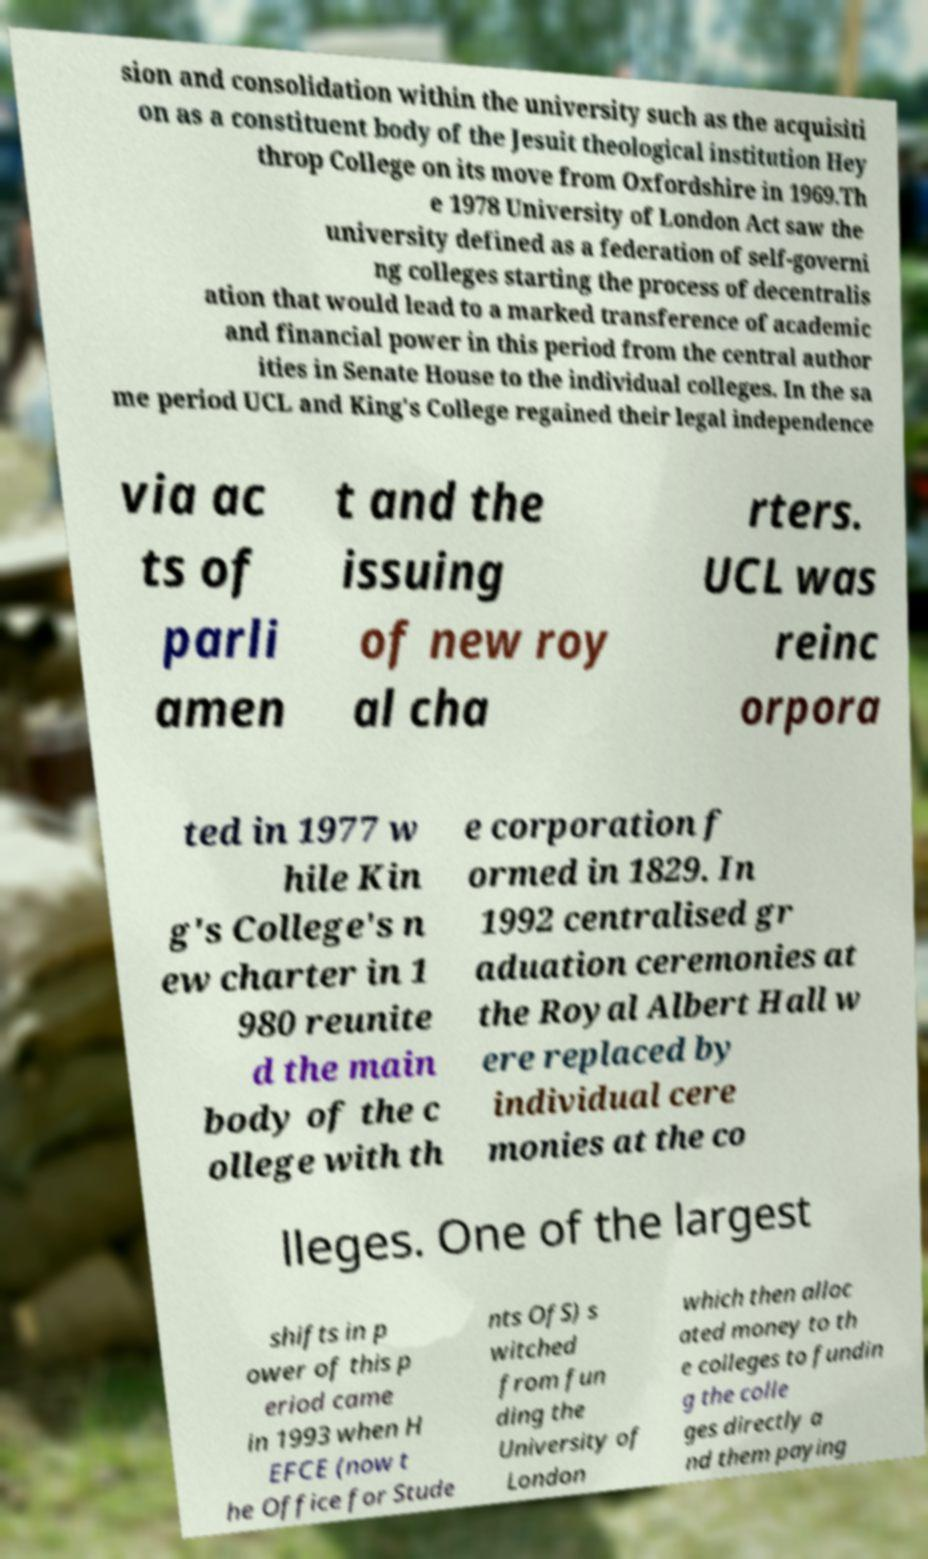Could you extract and type out the text from this image? sion and consolidation within the university such as the acquisiti on as a constituent body of the Jesuit theological institution Hey throp College on its move from Oxfordshire in 1969.Th e 1978 University of London Act saw the university defined as a federation of self-governi ng colleges starting the process of decentralis ation that would lead to a marked transference of academic and financial power in this period from the central author ities in Senate House to the individual colleges. In the sa me period UCL and King's College regained their legal independence via ac ts of parli amen t and the issuing of new roy al cha rters. UCL was reinc orpora ted in 1977 w hile Kin g's College's n ew charter in 1 980 reunite d the main body of the c ollege with th e corporation f ormed in 1829. In 1992 centralised gr aduation ceremonies at the Royal Albert Hall w ere replaced by individual cere monies at the co lleges. One of the largest shifts in p ower of this p eriod came in 1993 when H EFCE (now t he Office for Stude nts OfS) s witched from fun ding the University of London which then alloc ated money to th e colleges to fundin g the colle ges directly a nd them paying 